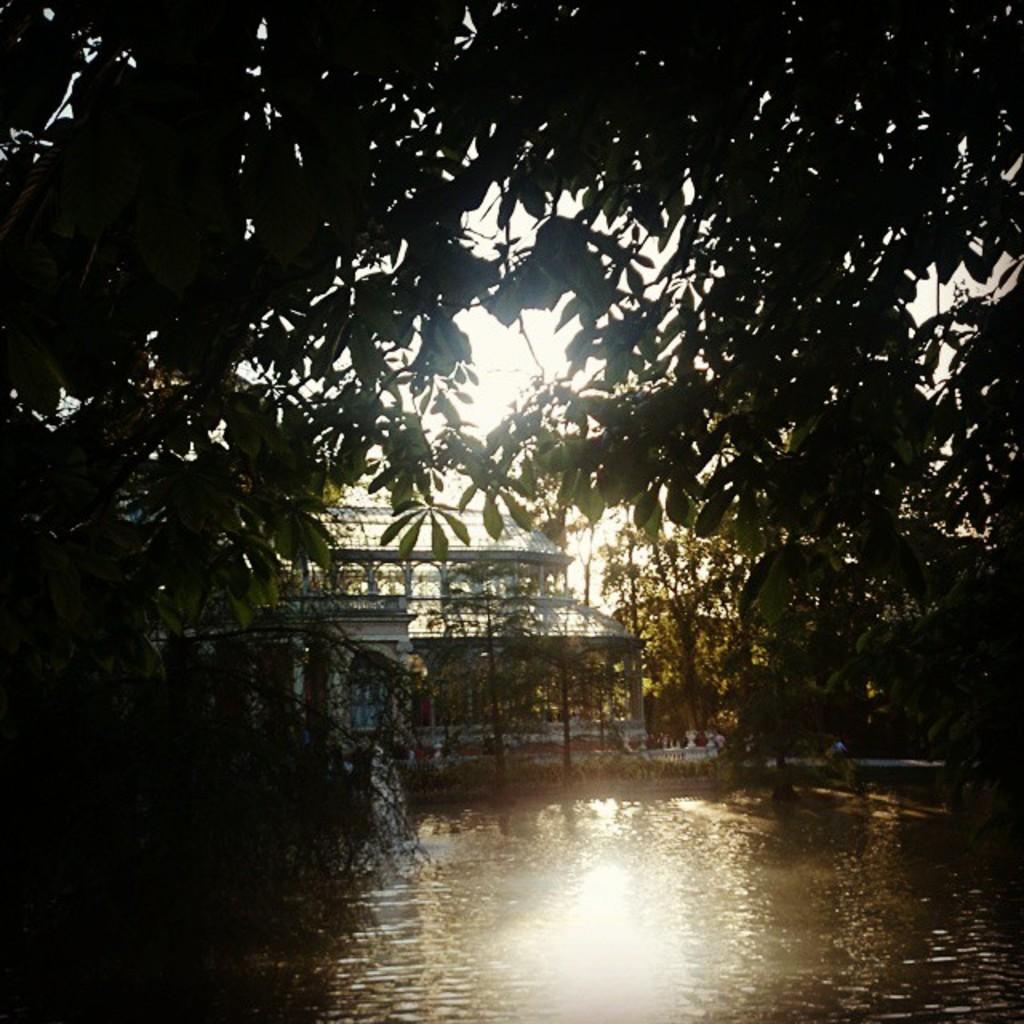Describe this image in one or two sentences. There is water, building and trees. 